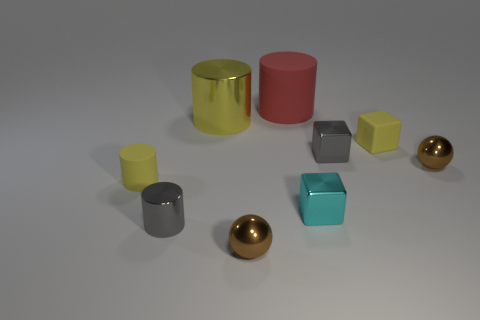Subtract all small matte cubes. How many cubes are left? 2 Add 1 small gray spheres. How many objects exist? 10 Subtract all purple spheres. How many yellow cylinders are left? 2 Subtract all red cylinders. How many cylinders are left? 3 Subtract all blue blocks. Subtract all cyan spheres. How many blocks are left? 3 Subtract all yellow rubber cylinders. Subtract all tiny gray cylinders. How many objects are left? 7 Add 5 gray things. How many gray things are left? 7 Add 4 cyan shiny objects. How many cyan shiny objects exist? 5 Subtract 1 gray blocks. How many objects are left? 8 Subtract all blocks. How many objects are left? 6 